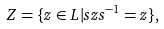Convert formula to latex. <formula><loc_0><loc_0><loc_500><loc_500>Z = \{ z \in L | s z s ^ { - 1 } = z \} ,</formula> 